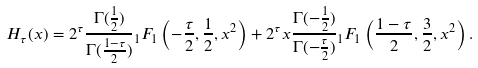Convert formula to latex. <formula><loc_0><loc_0><loc_500><loc_500>H _ { \tau } ( x ) = 2 ^ { \tau } \frac { \Gamma ( \frac { 1 } { 2 } ) } { \Gamma ( \frac { 1 - \tau } { 2 } ) } { _ { 1 } F _ { 1 } } \left ( - \frac { \tau } { 2 } , \frac { 1 } { 2 } , x ^ { 2 } \right ) + 2 ^ { \tau } x \frac { \Gamma ( - \frac { 1 } { 2 } ) } { \Gamma ( - \frac { \tau } { 2 } ) } { _ { 1 } F _ { 1 } } \left ( \frac { 1 - \tau } 2 , \frac { 3 } { 2 } , x ^ { 2 } \right ) .</formula> 